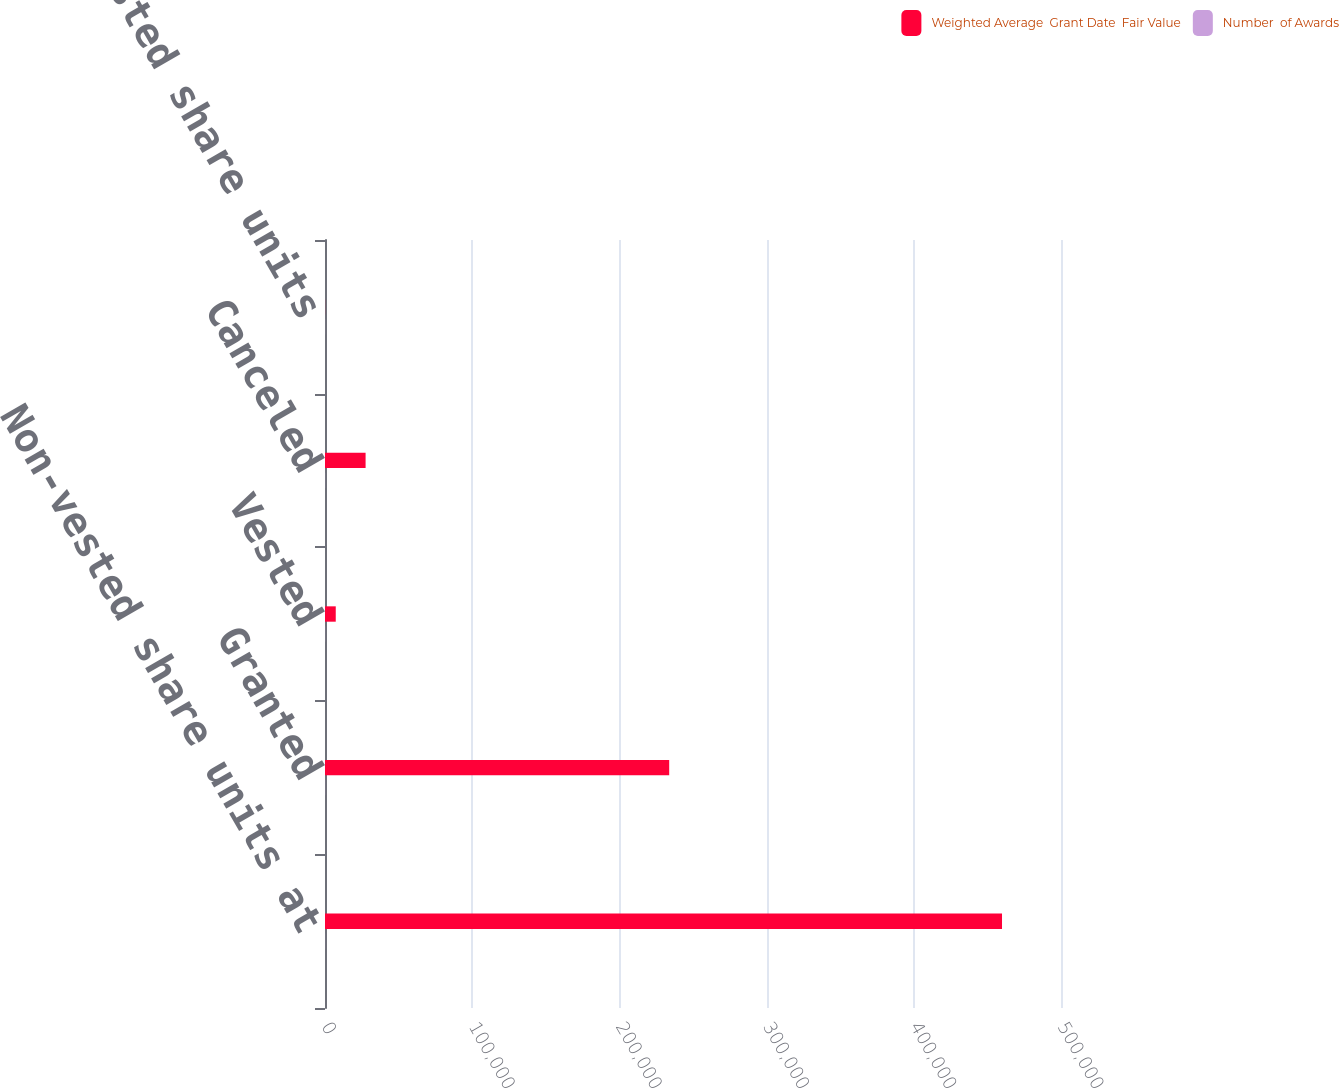Convert chart to OTSL. <chart><loc_0><loc_0><loc_500><loc_500><stacked_bar_chart><ecel><fcel>Non-vested share units at<fcel>Granted<fcel>Vested<fcel>Canceled<fcel>Non-vested share units<nl><fcel>Weighted Average  Grant Date  Fair Value<fcel>459929<fcel>233831<fcel>7301<fcel>27573<fcel>56.72<nl><fcel>Number  of Awards<fcel>32.36<fcel>56.72<fcel>53.81<fcel>54.11<fcel>39.86<nl></chart> 